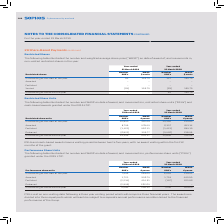According to Sophos Group's financial document, What is the vesting period of RSUs and cash-based awards? between two to five years, with no award vesting within the first 12 months of the grant.. The document states: "RSUs and cash-based awards have a vesting period between two to five years, with no award vesting within the first 12 months of the grant...." Also, What was the number of RSUs and cash-based awards outstanding at the end of the year in 2019? According to the financial document, 15,346 (in thousands). The relevant text states: "Outstanding at the end of the year 15,346 401.27 14,840 316.09..." Also, What are the types of movements in restricted share units (“RSUs”) and cash-based awards in the table? The document contains multiple relevant values: Awarded, Forfeited, Released. From the document: "Forfeited (1,421) 426.11 (1,421) 284.15 Released (6,822) 309.77 (5,426) 218.49 Awarded 8,749 478.44 6,337 453.14..." Additionally, In what year was the number of RSUs and cash-based awards outstanding at the end of the year larger? According to the financial document, 2019. The relevant text states: "Year-ended 31 March 2019 Year-ended 31 March 2018..." Also, can you calculate: What was the change in the number of RSUs and cash-based awards outstanding at the end of the year in 2019 from 2018? Based on the calculation: 15,346-14,840, the result is 506 (in thousands). This is based on the information: "Outstanding at the end of the year 15,346 401.27 14,840 316.09 Outstanding at the end of the year 15,346 401.27 14,840 316.09..." The key data points involved are: 14,840, 15,346. Also, can you calculate: What was the percentage change in the number of RSUs and cash-based awards outstanding at the end of the year in 2019 from 2018? To answer this question, I need to perform calculations using the financial data. The calculation is: (15,346-14,840)/14,840, which equals 3.41 (percentage). This is based on the information: "Outstanding at the end of the year 15,346 401.27 14,840 316.09 Outstanding at the end of the year 15,346 401.27 14,840 316.09..." The key data points involved are: 14,840, 15,346. 